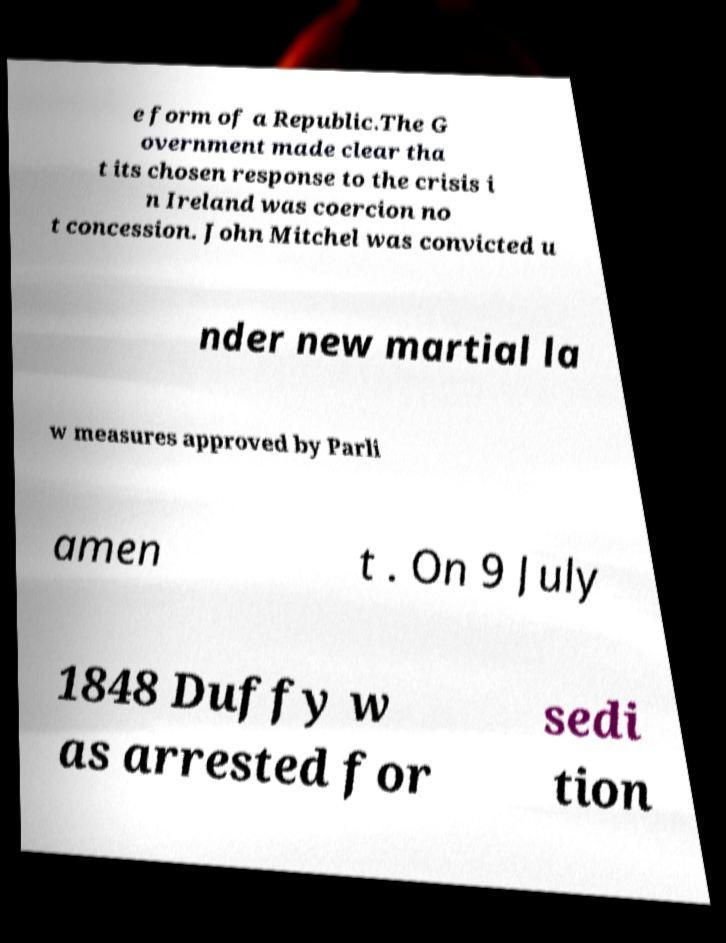What messages or text are displayed in this image? I need them in a readable, typed format. e form of a Republic.The G overnment made clear tha t its chosen response to the crisis i n Ireland was coercion no t concession. John Mitchel was convicted u nder new martial la w measures approved by Parli amen t . On 9 July 1848 Duffy w as arrested for sedi tion 